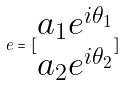<formula> <loc_0><loc_0><loc_500><loc_500>e = [ \begin{matrix} a _ { 1 } e ^ { i \theta _ { 1 } } \\ a _ { 2 } e ^ { i \theta _ { 2 } } \end{matrix} ]</formula> 